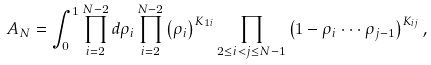<formula> <loc_0><loc_0><loc_500><loc_500>A _ { N } = \int _ { 0 } ^ { 1 } \prod _ { i = 2 } ^ { N - 2 } d \rho _ { i } \prod _ { i = 2 } ^ { N - 2 } \left ( \rho _ { i } \right ) ^ { K _ { 1 i } } \prod _ { 2 \leq i < j \leq N - 1 } \left ( 1 - \rho _ { i } \cdot \cdot \cdot \rho _ { j - 1 } \right ) ^ { K _ { i j } } ,</formula> 